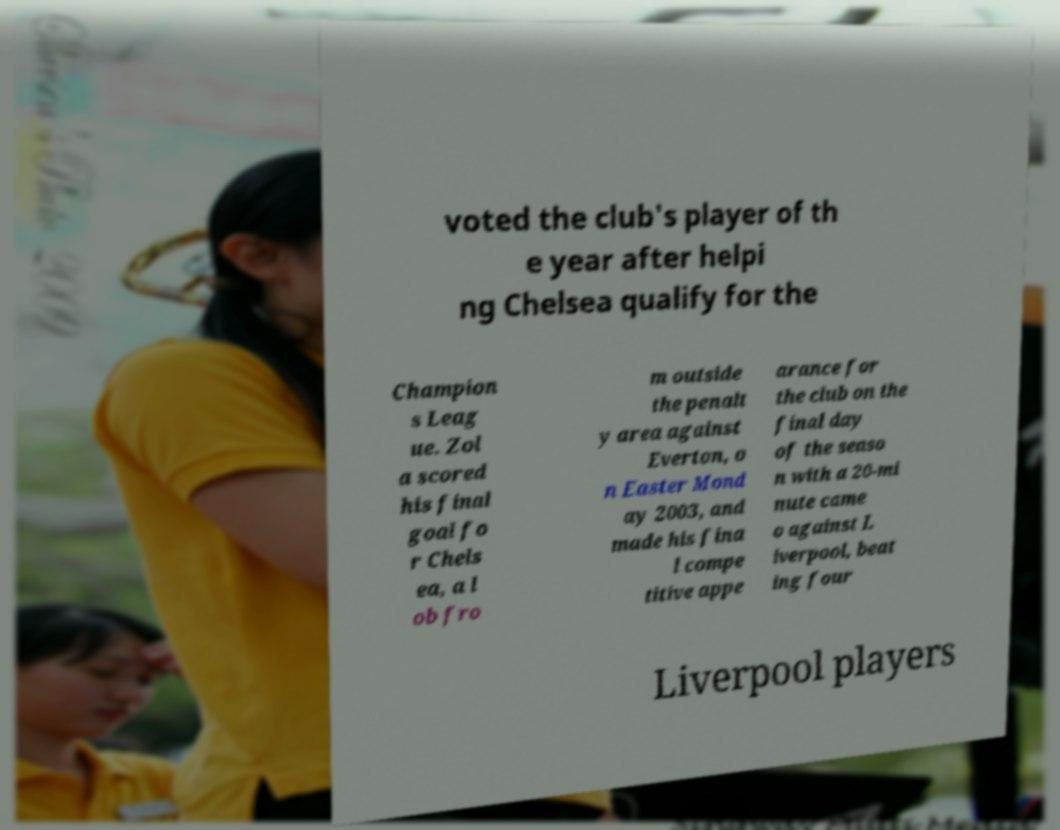There's text embedded in this image that I need extracted. Can you transcribe it verbatim? voted the club's player of th e year after helpi ng Chelsea qualify for the Champion s Leag ue. Zol a scored his final goal fo r Chels ea, a l ob fro m outside the penalt y area against Everton, o n Easter Mond ay 2003, and made his fina l compe titive appe arance for the club on the final day of the seaso n with a 20-mi nute came o against L iverpool, beat ing four Liverpool players 